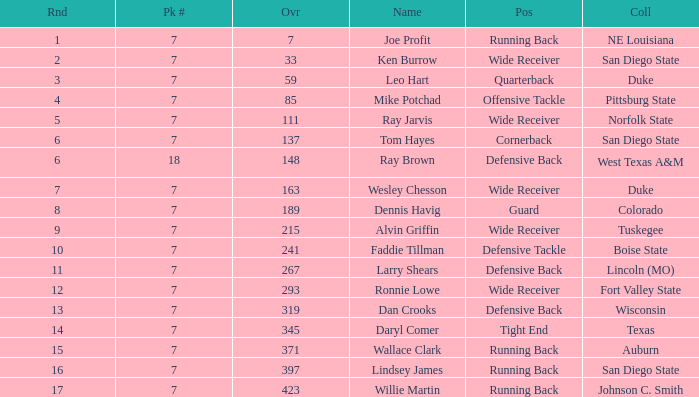What numbered pick was the player from texas? 1.0. I'm looking to parse the entire table for insights. Could you assist me with that? {'header': ['Rnd', 'Pk #', 'Ovr', 'Name', 'Pos', 'Coll'], 'rows': [['1', '7', '7', 'Joe Profit', 'Running Back', 'NE Louisiana'], ['2', '7', '33', 'Ken Burrow', 'Wide Receiver', 'San Diego State'], ['3', '7', '59', 'Leo Hart', 'Quarterback', 'Duke'], ['4', '7', '85', 'Mike Potchad', 'Offensive Tackle', 'Pittsburg State'], ['5', '7', '111', 'Ray Jarvis', 'Wide Receiver', 'Norfolk State'], ['6', '7', '137', 'Tom Hayes', 'Cornerback', 'San Diego State'], ['6', '18', '148', 'Ray Brown', 'Defensive Back', 'West Texas A&M'], ['7', '7', '163', 'Wesley Chesson', 'Wide Receiver', 'Duke'], ['8', '7', '189', 'Dennis Havig', 'Guard', 'Colorado'], ['9', '7', '215', 'Alvin Griffin', 'Wide Receiver', 'Tuskegee'], ['10', '7', '241', 'Faddie Tillman', 'Defensive Tackle', 'Boise State'], ['11', '7', '267', 'Larry Shears', 'Defensive Back', 'Lincoln (MO)'], ['12', '7', '293', 'Ronnie Lowe', 'Wide Receiver', 'Fort Valley State'], ['13', '7', '319', 'Dan Crooks', 'Defensive Back', 'Wisconsin'], ['14', '7', '345', 'Daryl Comer', 'Tight End', 'Texas'], ['15', '7', '371', 'Wallace Clark', 'Running Back', 'Auburn'], ['16', '7', '397', 'Lindsey James', 'Running Back', 'San Diego State'], ['17', '7', '423', 'Willie Martin', 'Running Back', 'Johnson C. Smith']]} 